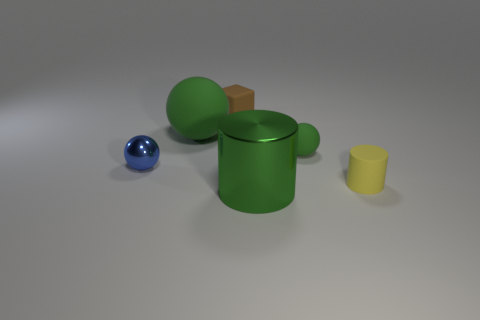How many other objects are the same material as the large cylinder?
Offer a very short reply. 1. Does the big shiny thing have the same shape as the small rubber thing that is in front of the small blue object?
Give a very brief answer. Yes. How many objects are balls that are on the right side of the big green rubber thing or balls that are behind the blue shiny ball?
Offer a very short reply. 2. Is the number of tiny yellow rubber things behind the big green ball less than the number of tiny cylinders?
Provide a succinct answer. Yes. Does the tiny brown thing have the same material as the cylinder on the left side of the small green rubber object?
Your answer should be compact. No. What is the material of the big green ball?
Keep it short and to the point. Rubber. The ball that is in front of the green object on the right side of the shiny object right of the block is made of what material?
Give a very brief answer. Metal. Do the tiny cylinder and the shiny object on the left side of the big metallic thing have the same color?
Provide a succinct answer. No. Is there any other thing that is the same shape as the small green thing?
Give a very brief answer. Yes. The small sphere to the left of the large green metallic object on the right side of the tiny blue ball is what color?
Offer a terse response. Blue. 